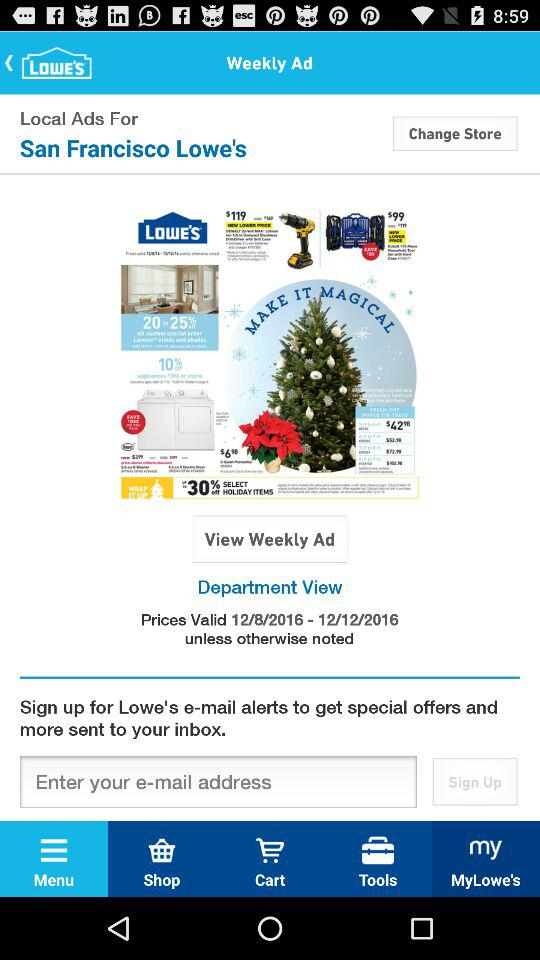How long are the prices valid? The prices are valid from December 8, 2016 to December 12, 2016. 